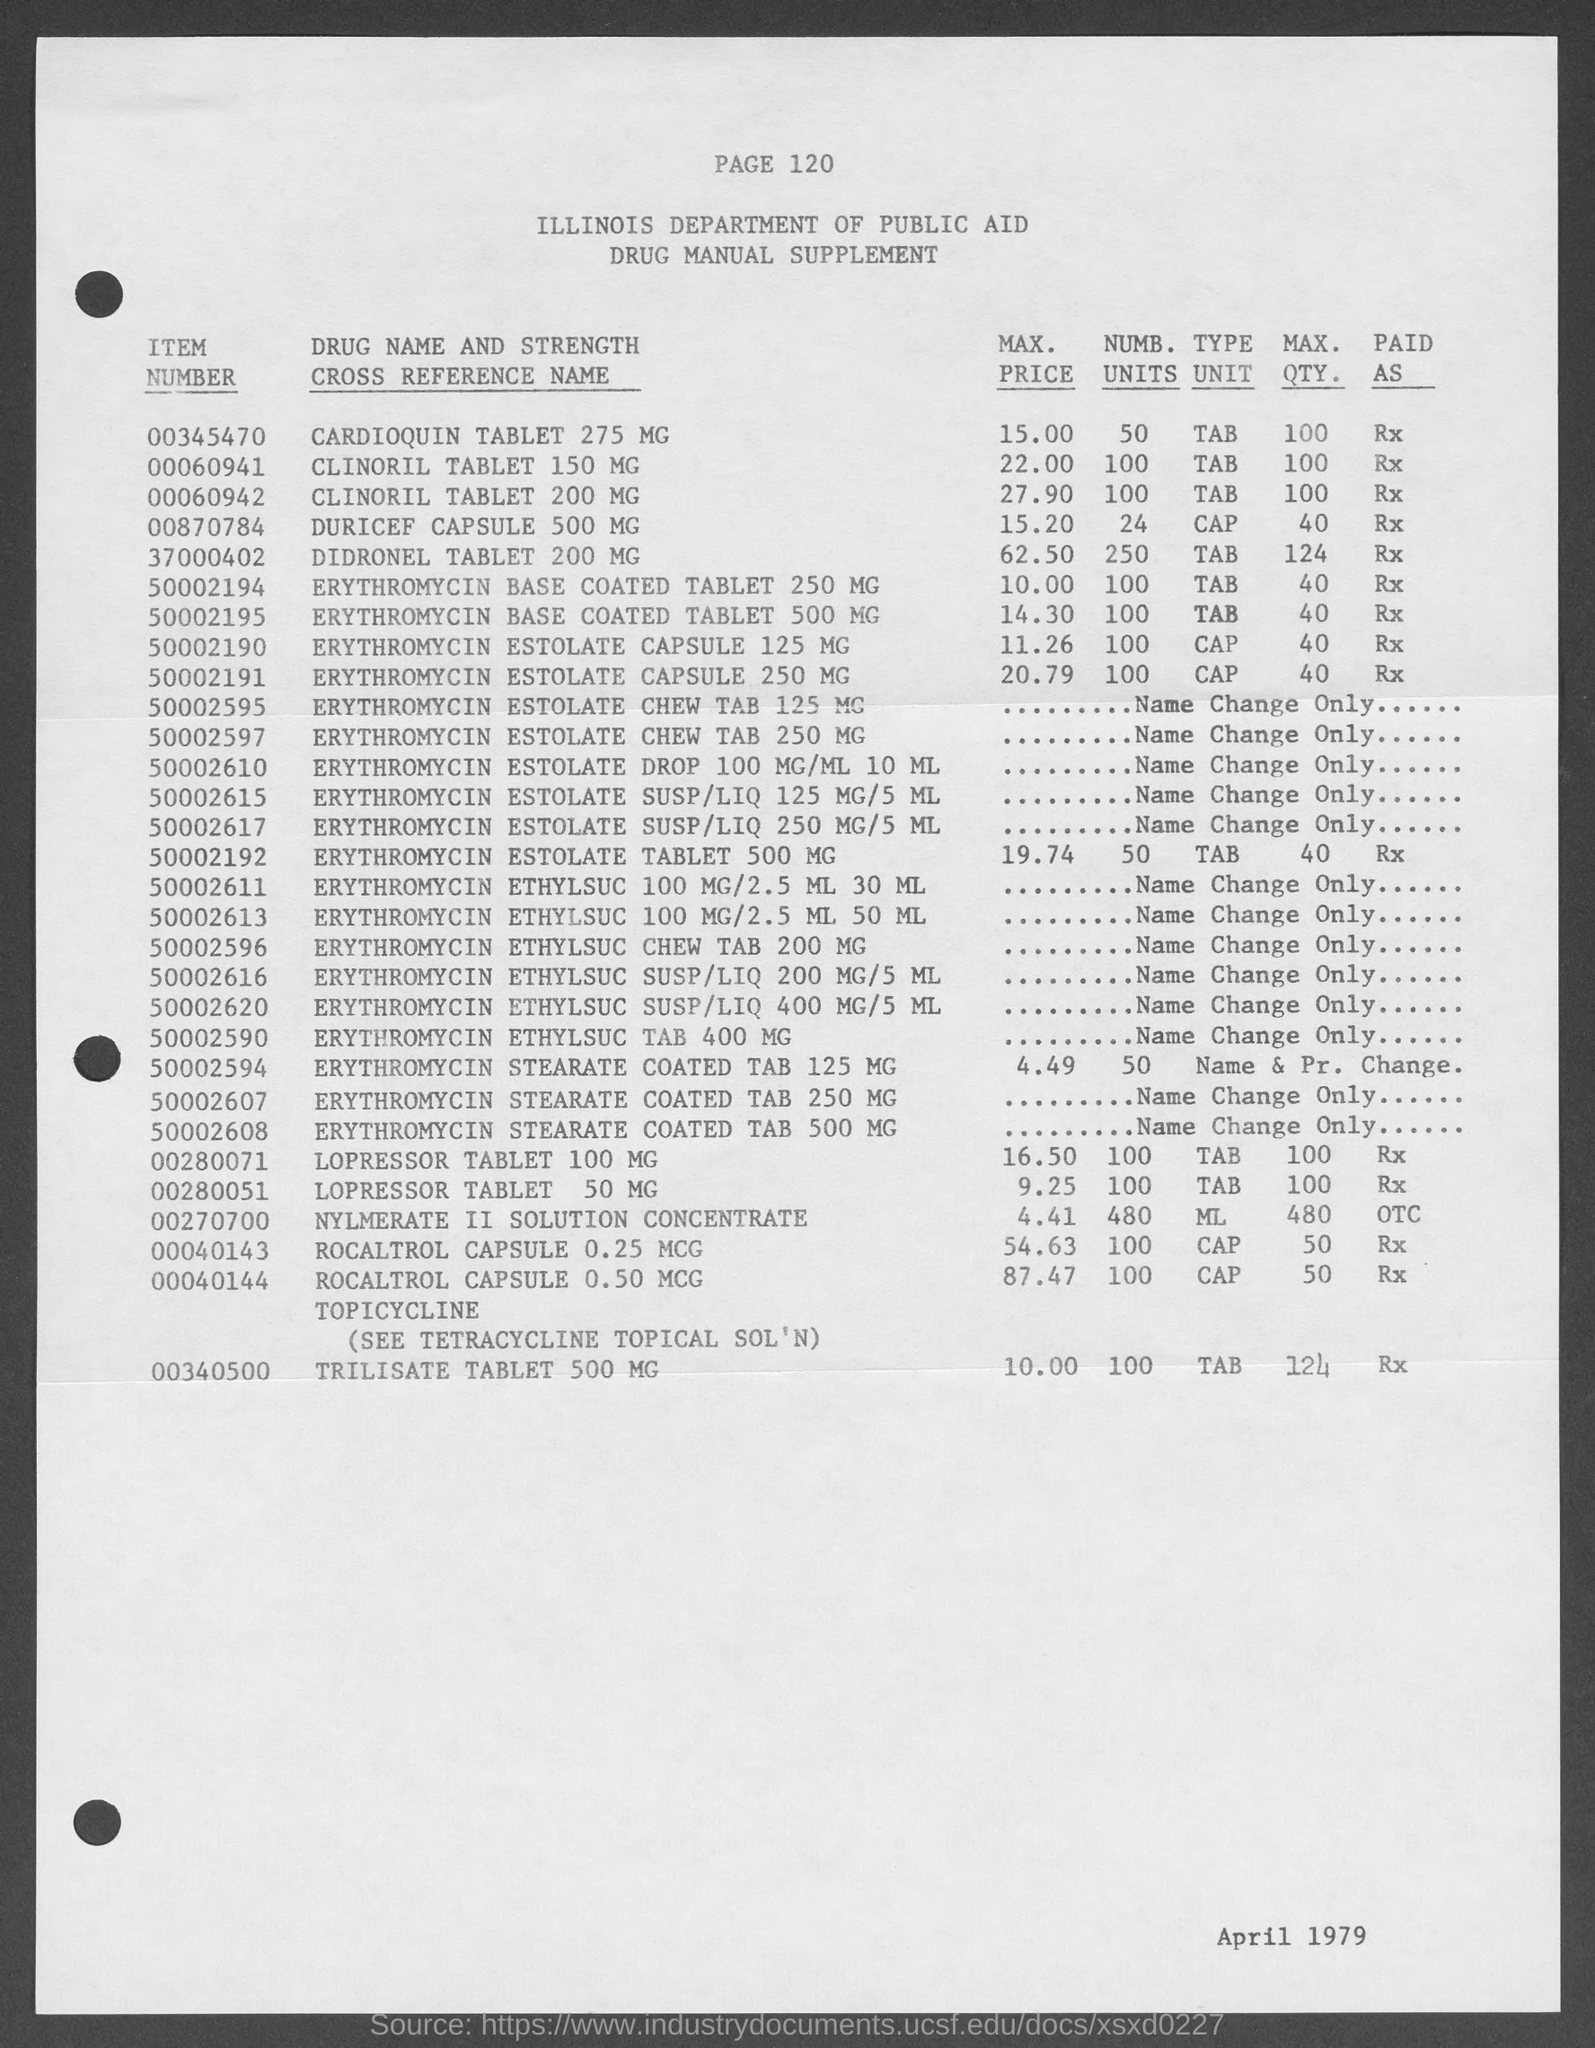What is the Max. Price of CLINORIL Tablet 150MG given in the document?
Give a very brief answer. 22.00. What is the Item Number of CLINORIL Tablet 200MG given in the document?
Provide a succinct answer. 00060942. What is the Max. Quantity of DURICEF Capsule 500MG given in the document?
Give a very brief answer. 40. What is the Max. Price of TRILISATE Tablet 500MG as per the document?
Offer a very short reply. 10.00. What is the Item Number of DIDRONEL Tablet 200MG given in the document?
Your answer should be very brief. 37000402. What is the Max. Quantity of TRILISATE Tablet 500MG as per the document?
Offer a terse response. 124. 